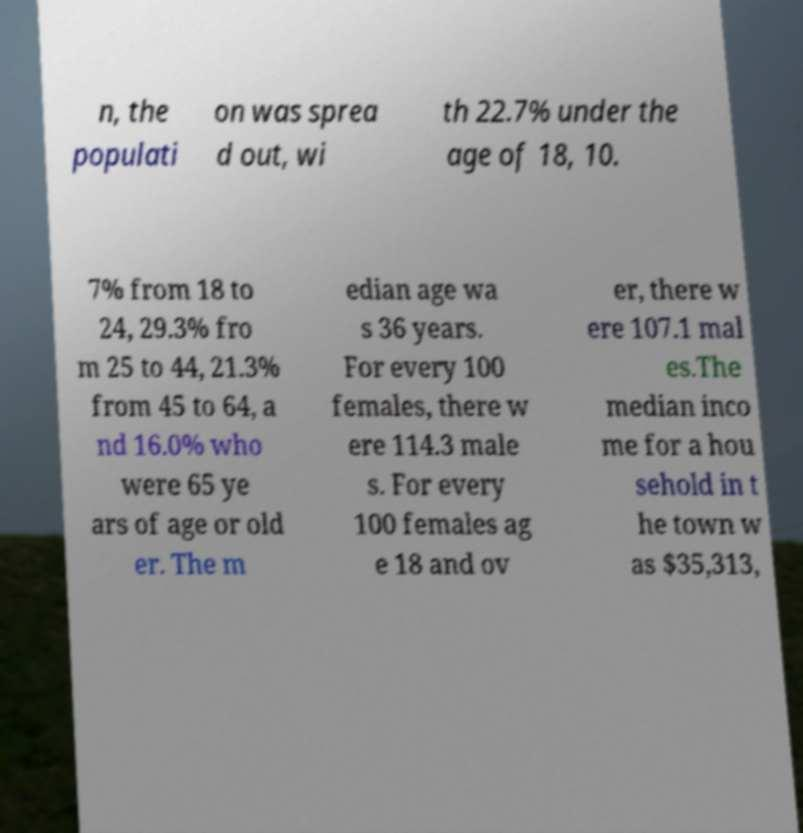Please identify and transcribe the text found in this image. n, the populati on was sprea d out, wi th 22.7% under the age of 18, 10. 7% from 18 to 24, 29.3% fro m 25 to 44, 21.3% from 45 to 64, a nd 16.0% who were 65 ye ars of age or old er. The m edian age wa s 36 years. For every 100 females, there w ere 114.3 male s. For every 100 females ag e 18 and ov er, there w ere 107.1 mal es.The median inco me for a hou sehold in t he town w as $35,313, 